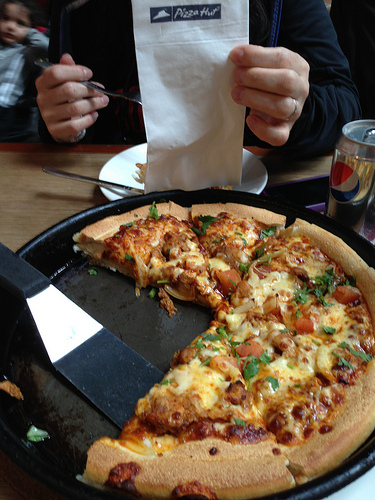Please provide a short description for this region: [0.43, 0.01, 0.57, 0.08]. This region shows black writing on a receipt. 